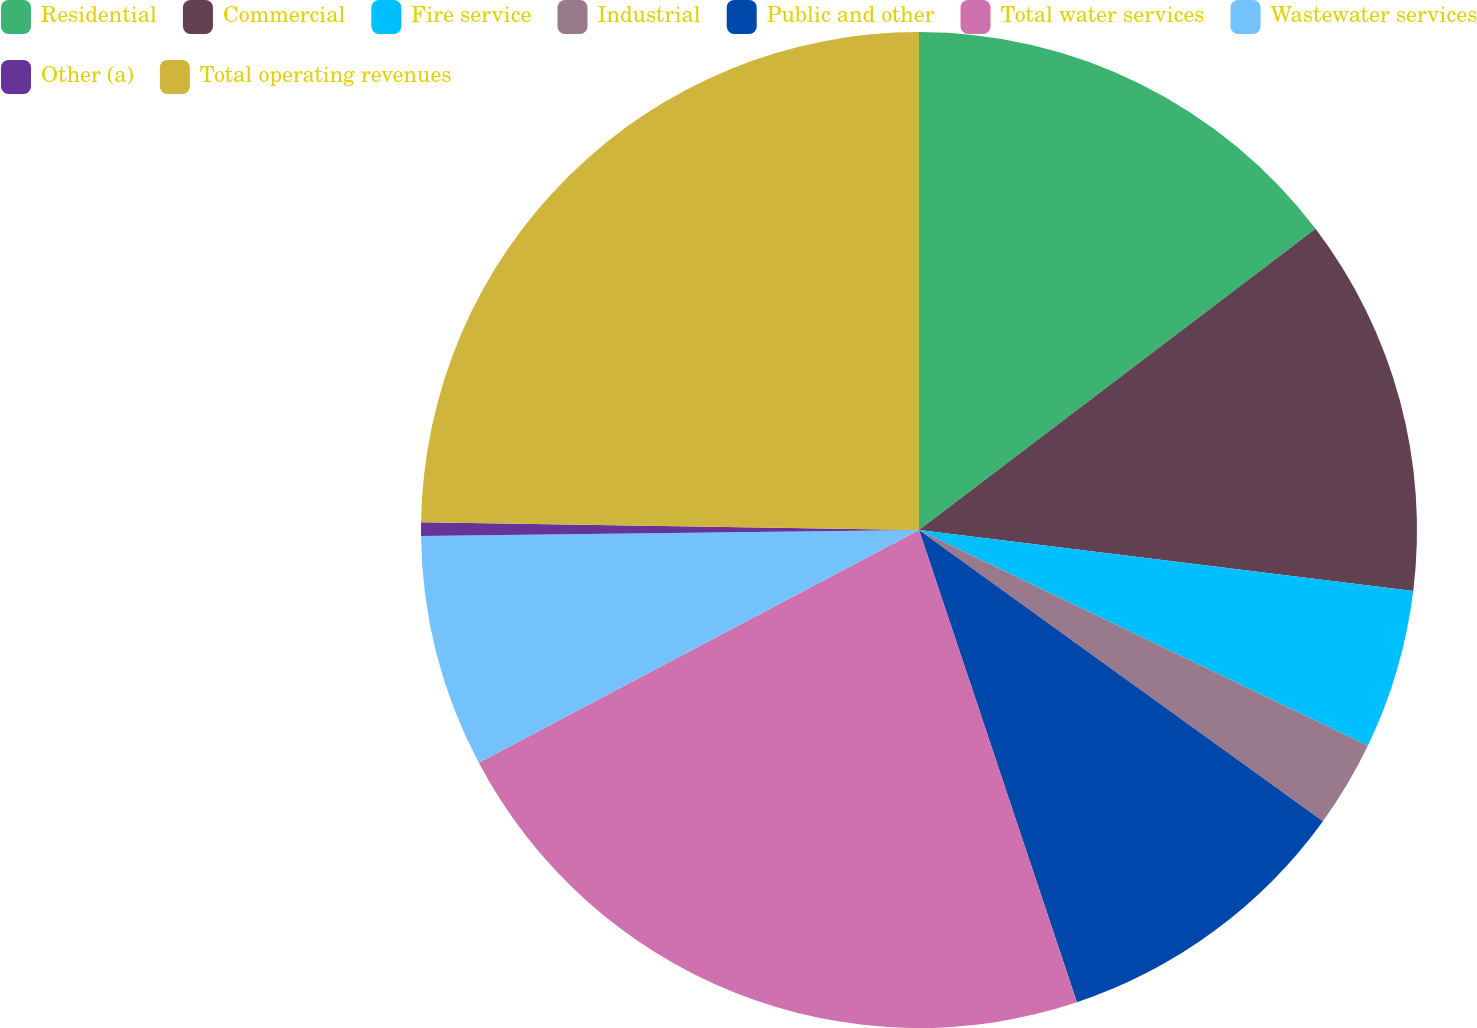Convert chart to OTSL. <chart><loc_0><loc_0><loc_500><loc_500><pie_chart><fcel>Residential<fcel>Commercial<fcel>Fire service<fcel>Industrial<fcel>Public and other<fcel>Total water services<fcel>Wastewater services<fcel>Other (a)<fcel>Total operating revenues<nl><fcel>14.66%<fcel>12.29%<fcel>5.18%<fcel>2.81%<fcel>9.92%<fcel>22.39%<fcel>7.55%<fcel>0.44%<fcel>24.75%<nl></chart> 